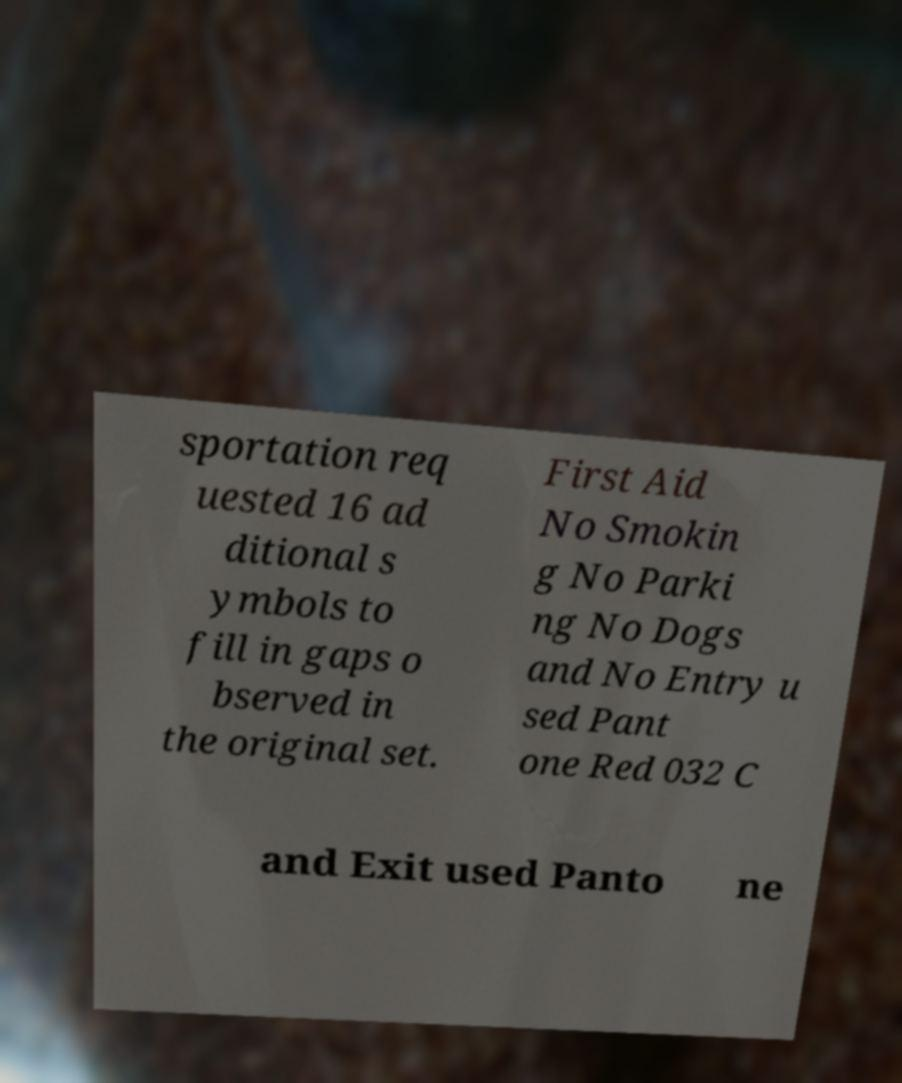There's text embedded in this image that I need extracted. Can you transcribe it verbatim? sportation req uested 16 ad ditional s ymbols to fill in gaps o bserved in the original set. First Aid No Smokin g No Parki ng No Dogs and No Entry u sed Pant one Red 032 C and Exit used Panto ne 